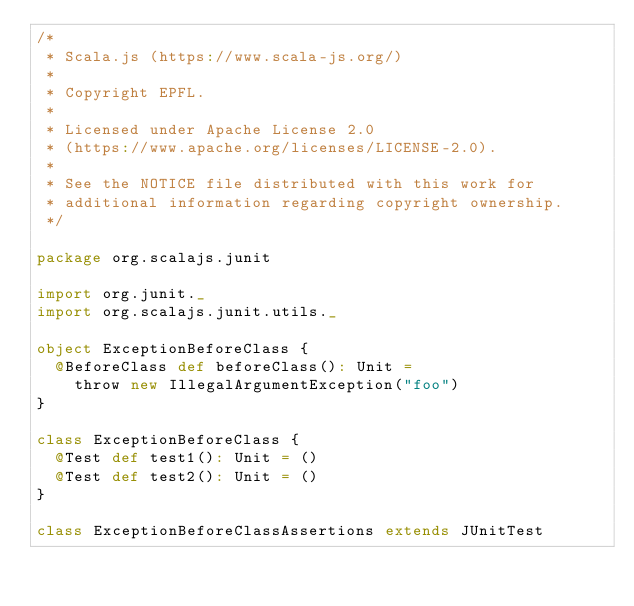<code> <loc_0><loc_0><loc_500><loc_500><_Scala_>/*
 * Scala.js (https://www.scala-js.org/)
 *
 * Copyright EPFL.
 *
 * Licensed under Apache License 2.0
 * (https://www.apache.org/licenses/LICENSE-2.0).
 *
 * See the NOTICE file distributed with this work for
 * additional information regarding copyright ownership.
 */

package org.scalajs.junit

import org.junit._
import org.scalajs.junit.utils._

object ExceptionBeforeClass {
  @BeforeClass def beforeClass(): Unit =
    throw new IllegalArgumentException("foo")
}

class ExceptionBeforeClass {
  @Test def test1(): Unit = ()
  @Test def test2(): Unit = ()
}

class ExceptionBeforeClassAssertions extends JUnitTest
</code> 